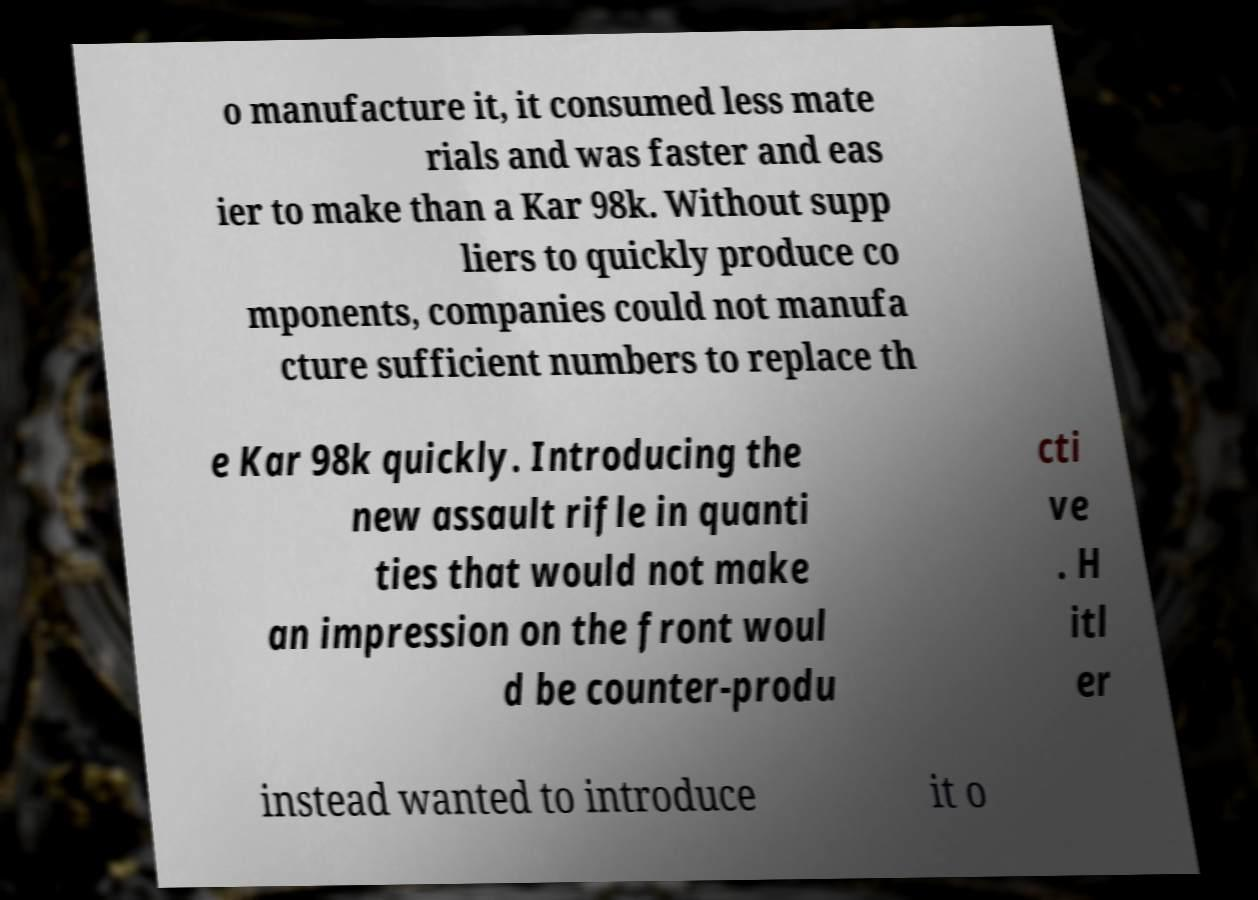Can you read and provide the text displayed in the image?This photo seems to have some interesting text. Can you extract and type it out for me? o manufacture it, it consumed less mate rials and was faster and eas ier to make than a Kar 98k. Without supp liers to quickly produce co mponents, companies could not manufa cture sufficient numbers to replace th e Kar 98k quickly. Introducing the new assault rifle in quanti ties that would not make an impression on the front woul d be counter-produ cti ve . H itl er instead wanted to introduce it o 